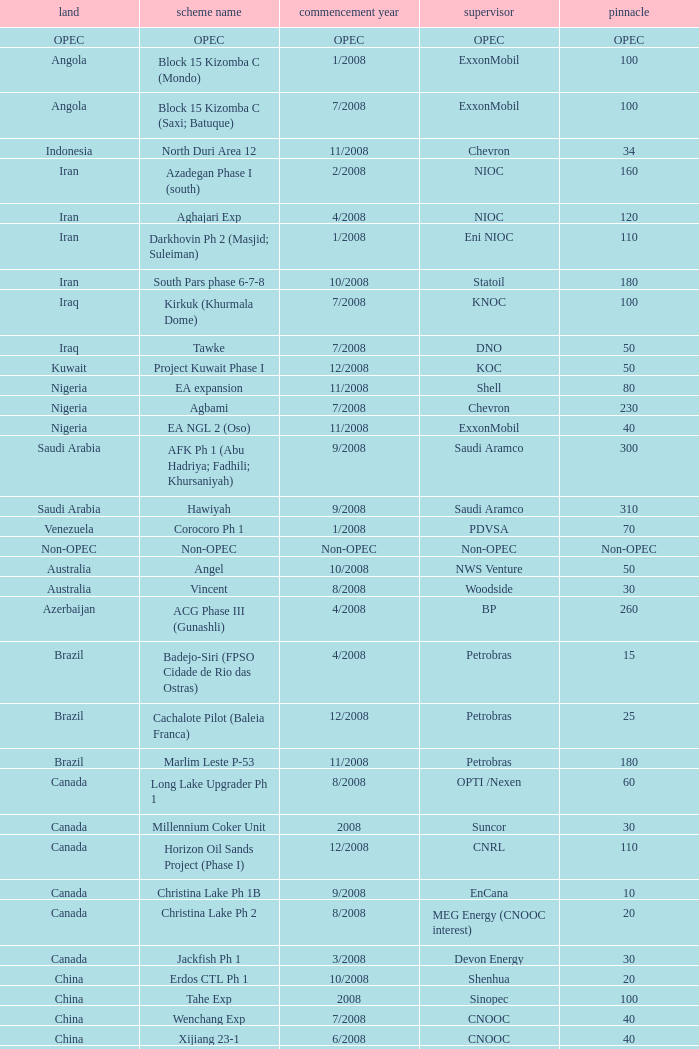What is the Project Name with a Country that is opec? OPEC. 